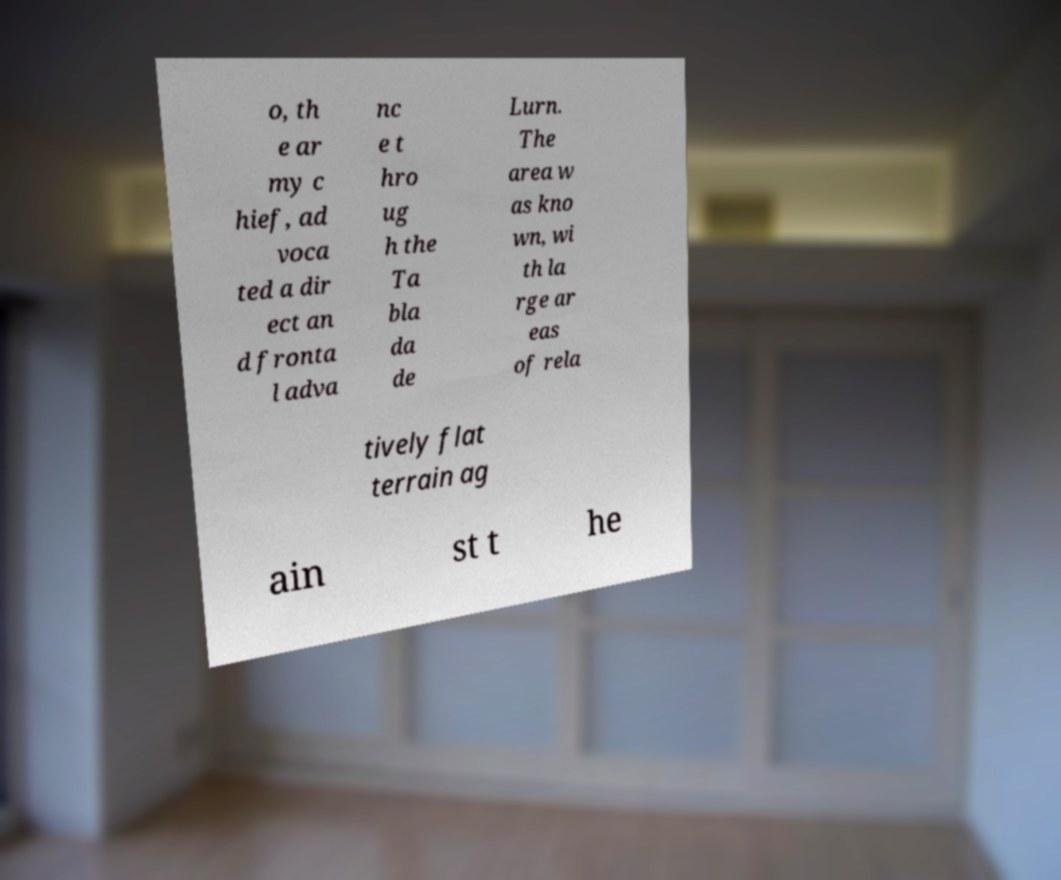For documentation purposes, I need the text within this image transcribed. Could you provide that? o, th e ar my c hief, ad voca ted a dir ect an d fronta l adva nc e t hro ug h the Ta bla da de Lurn. The area w as kno wn, wi th la rge ar eas of rela tively flat terrain ag ain st t he 